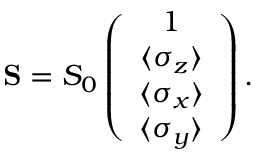<formula> <loc_0><loc_0><loc_500><loc_500>\begin{array} { r } { { S } = S _ { 0 } \left ( \begin{array} { c } { 1 } \\ { \langle \sigma _ { z } \rangle } \\ { \langle \sigma _ { x } \rangle } \\ { \langle \sigma _ { y } \rangle } \end{array} \right ) . } \end{array}</formula> 